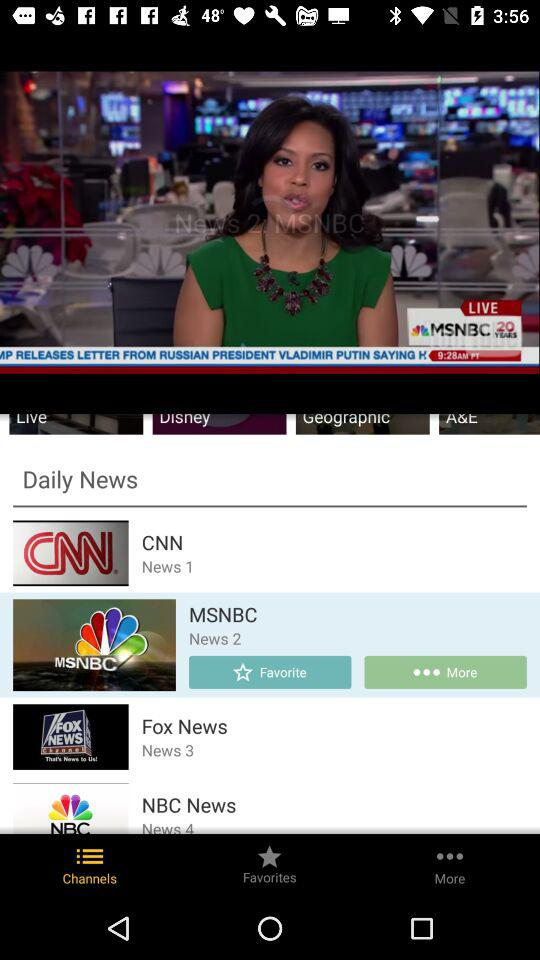What are the daily news channels? The daily news channels are "CNN", "MSNBC", "Fox News" and "NBC News". 